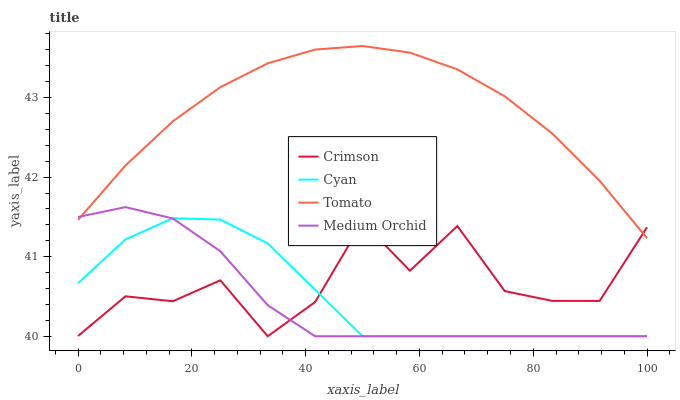Does Medium Orchid have the minimum area under the curve?
Answer yes or no. Yes. Does Tomato have the maximum area under the curve?
Answer yes or no. Yes. Does Cyan have the minimum area under the curve?
Answer yes or no. No. Does Cyan have the maximum area under the curve?
Answer yes or no. No. Is Tomato the smoothest?
Answer yes or no. Yes. Is Crimson the roughest?
Answer yes or no. Yes. Is Cyan the smoothest?
Answer yes or no. No. Is Cyan the roughest?
Answer yes or no. No. Does Crimson have the lowest value?
Answer yes or no. Yes. Does Tomato have the lowest value?
Answer yes or no. No. Does Tomato have the highest value?
Answer yes or no. Yes. Does Cyan have the highest value?
Answer yes or no. No. Is Cyan less than Tomato?
Answer yes or no. Yes. Is Tomato greater than Cyan?
Answer yes or no. Yes. Does Cyan intersect Medium Orchid?
Answer yes or no. Yes. Is Cyan less than Medium Orchid?
Answer yes or no. No. Is Cyan greater than Medium Orchid?
Answer yes or no. No. Does Cyan intersect Tomato?
Answer yes or no. No. 